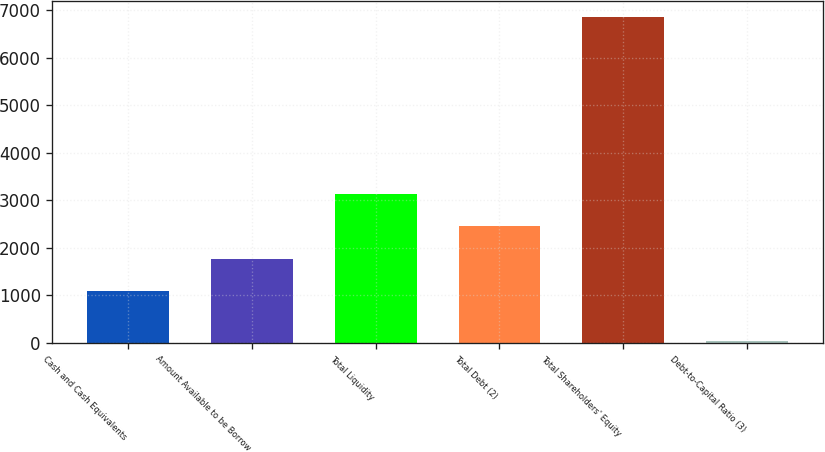Convert chart. <chart><loc_0><loc_0><loc_500><loc_500><bar_chart><fcel>Cash and Cash Equivalents<fcel>Amount Available to be Borrow<fcel>Total Liquidity<fcel>Total Debt (2)<fcel>Total Shareholders' Equity<fcel>Debt-to-Capital Ratio (3)<nl><fcel>1081<fcel>1763.3<fcel>3127.9<fcel>2445.6<fcel>6848<fcel>25<nl></chart> 